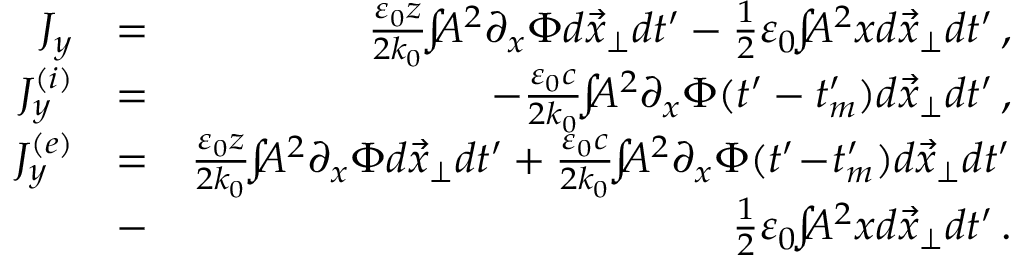<formula> <loc_0><loc_0><loc_500><loc_500>\begin{array} { r l r } { J _ { y } } & { = } & { \frac { \varepsilon _ { 0 } z } { 2 k _ { 0 } } \, \int \, A ^ { 2 } \partial _ { x } \Phi d \vec { x } _ { \perp } d t ^ { \prime } - \frac { 1 } { 2 } \varepsilon _ { 0 } \, \int \, A ^ { 2 } x d \vec { x } _ { \perp } d t ^ { \prime } \, , } \\ { J _ { y } ^ { ( i ) } } & { = } & { - \frac { \varepsilon _ { 0 } c } { 2 k _ { 0 } } \, \int \, A ^ { 2 } \partial _ { x } \Phi ( t ^ { \prime } - t _ { m } ^ { \prime } ) d \vec { x } _ { \perp } d t ^ { \prime } \, , } \\ { J _ { y } ^ { ( e ) } } & { = } & { \frac { \varepsilon _ { 0 } z } { 2 k _ { 0 } } \, \int \, A ^ { 2 } \partial _ { x } \Phi d \vec { x } _ { \perp } d t ^ { \prime } + \frac { \varepsilon _ { 0 } c } { 2 k _ { 0 } } \, \int \, A ^ { 2 } \partial _ { x } \Phi ( t ^ { \prime } \, - \, t _ { m } ^ { \prime } ) d \vec { x } _ { \perp } d t ^ { \prime } } \\ & { - } & { \frac { 1 } { 2 } \varepsilon _ { 0 } \, \int \, A ^ { 2 } x d \vec { x } _ { \perp } d t ^ { \prime } \, . } \end{array}</formula> 